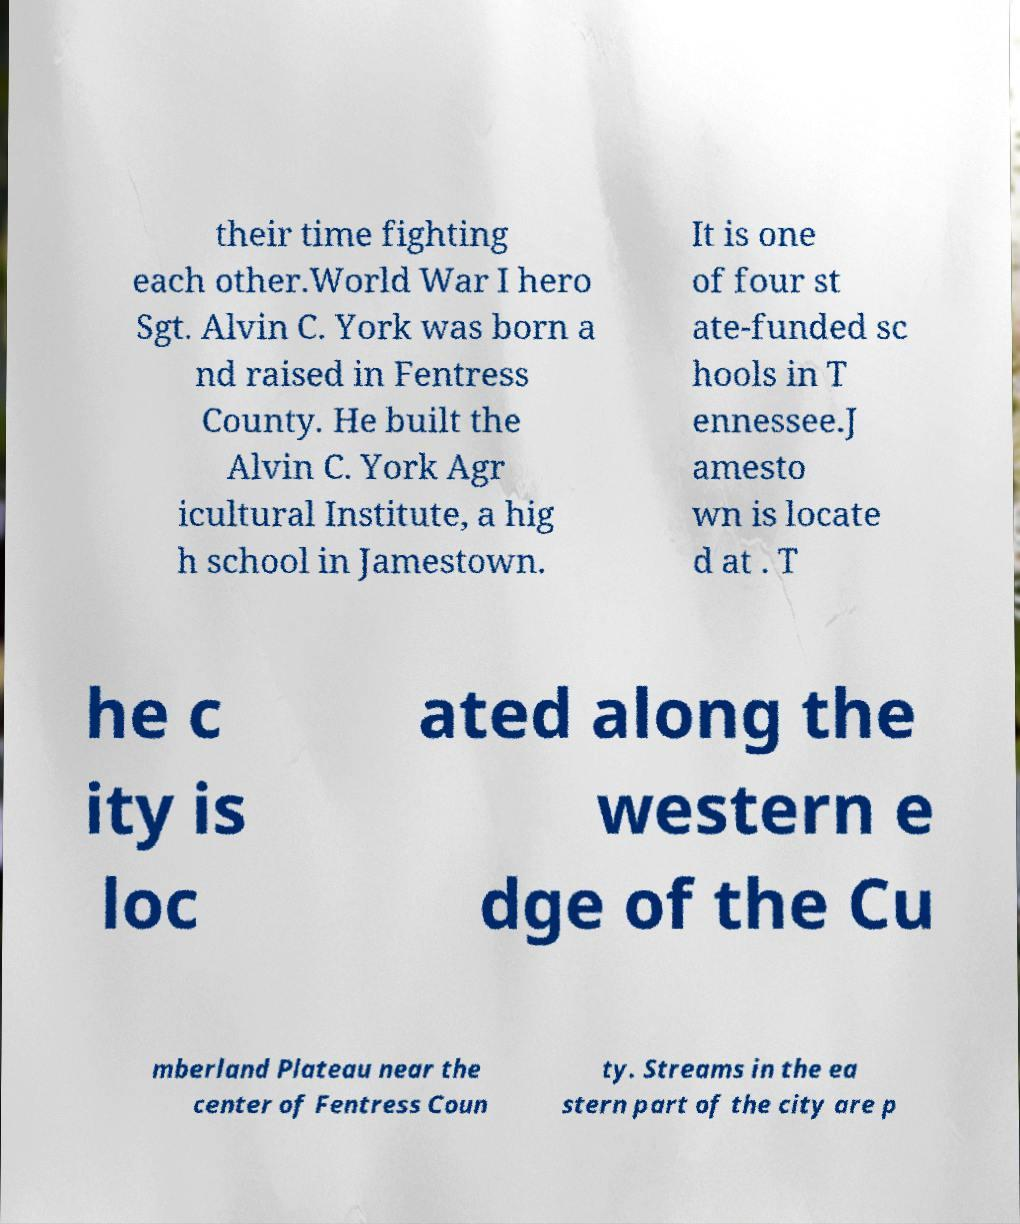Please read and relay the text visible in this image. What does it say? their time fighting each other.World War I hero Sgt. Alvin C. York was born a nd raised in Fentress County. He built the Alvin C. York Agr icultural Institute, a hig h school in Jamestown. It is one of four st ate-funded sc hools in T ennessee.J amesto wn is locate d at . T he c ity is loc ated along the western e dge of the Cu mberland Plateau near the center of Fentress Coun ty. Streams in the ea stern part of the city are p 